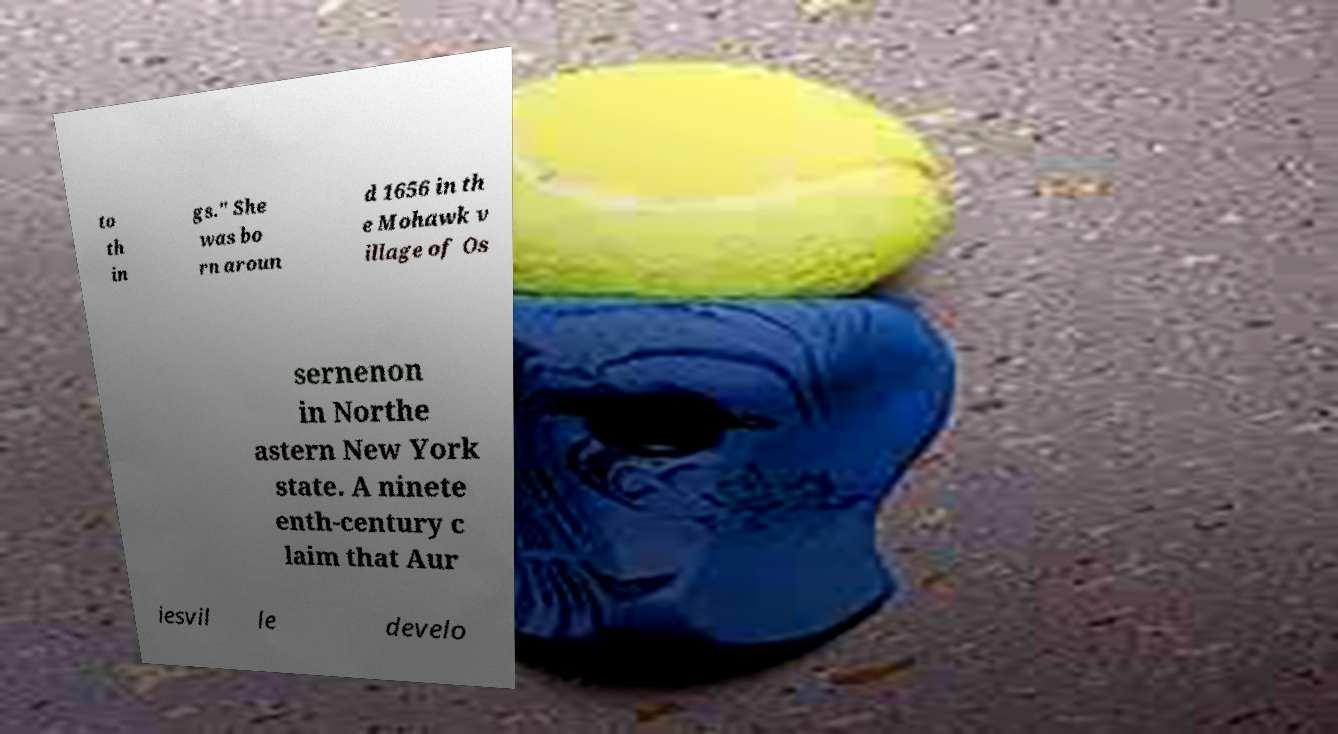Can you accurately transcribe the text from the provided image for me? to th in gs." She was bo rn aroun d 1656 in th e Mohawk v illage of Os sernenon in Northe astern New York state. A ninete enth-century c laim that Aur iesvil le develo 